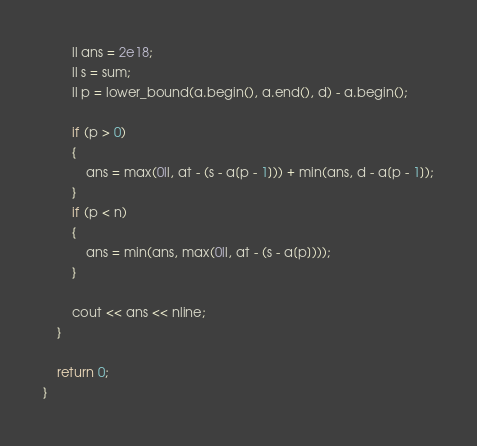<code> <loc_0><loc_0><loc_500><loc_500><_C++_>        ll ans = 2e18;
        ll s = sum;
        ll p = lower_bound(a.begin(), a.end(), d) - a.begin();

        if (p > 0)
        {
            ans = max(0ll, at - (s - a[p - 1])) + min(ans, d - a[p - 1]);
        }
        if (p < n)
        {
            ans = min(ans, max(0ll, at - (s - a[p])));
        }

        cout << ans << nline;
    }

    return 0;
}</code> 